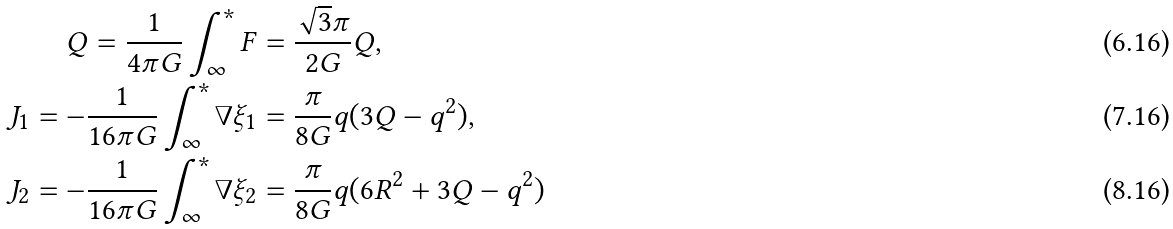<formula> <loc_0><loc_0><loc_500><loc_500>Q = \frac { 1 } { 4 \pi G } \int _ { \infty } ^ { * } F & = \frac { \sqrt { 3 } \pi } { 2 G } Q , \\ J _ { 1 } = - \frac { 1 } { 1 6 \pi G } \int _ { \infty } ^ { * } \nabla \xi _ { 1 } & = \frac { \pi } { 8 G } q ( 3 Q - q ^ { 2 } ) , \\ J _ { 2 } = - \frac { 1 } { 1 6 \pi G } \int _ { \infty } ^ { * } \nabla \xi _ { 2 } & = \frac { \pi } { 8 G } q ( 6 R ^ { 2 } + 3 Q - q ^ { 2 } )</formula> 